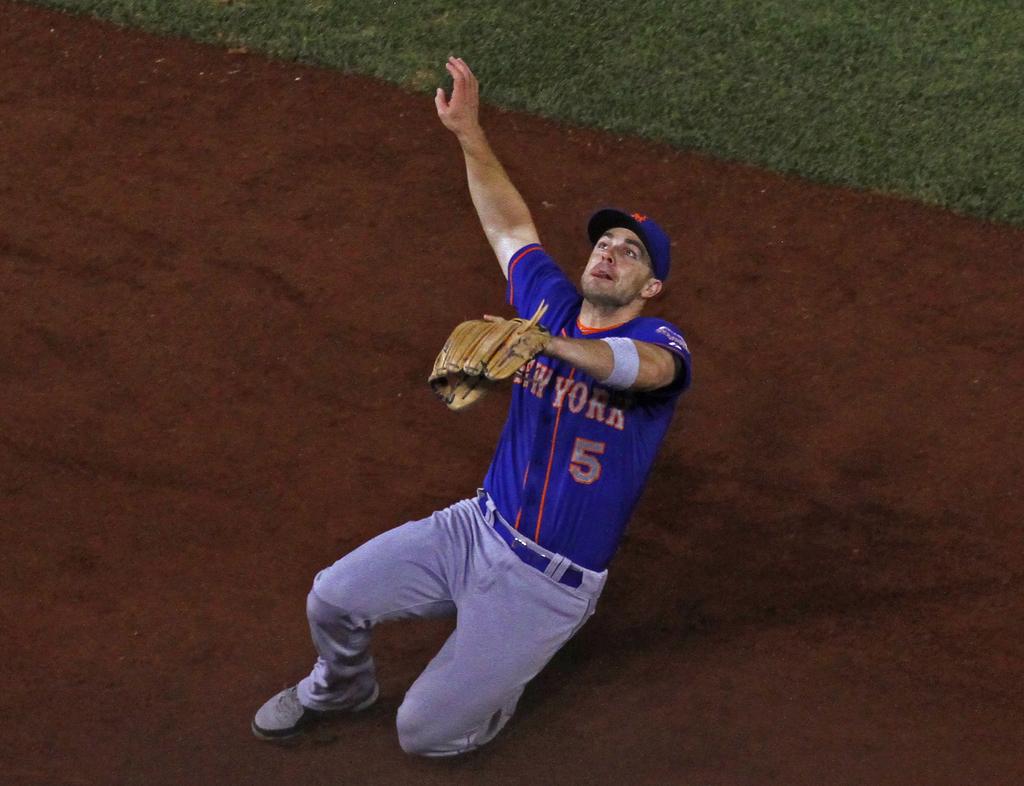What's this player's number?
Provide a short and direct response. 5. What team does this player play for?
Give a very brief answer. New york. 